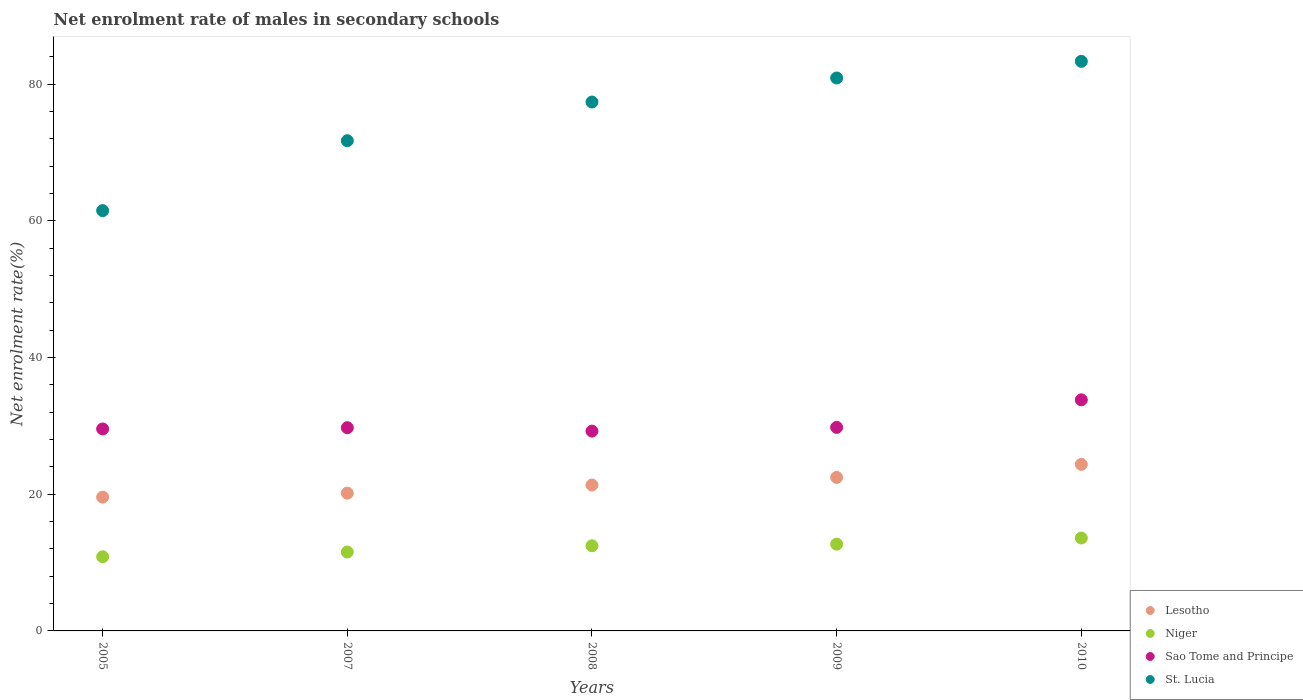Is the number of dotlines equal to the number of legend labels?
Your answer should be compact. Yes. What is the net enrolment rate of males in secondary schools in Niger in 2009?
Offer a terse response. 12.7. Across all years, what is the maximum net enrolment rate of males in secondary schools in Sao Tome and Principe?
Provide a short and direct response. 33.8. Across all years, what is the minimum net enrolment rate of males in secondary schools in Niger?
Your response must be concise. 10.85. In which year was the net enrolment rate of males in secondary schools in St. Lucia maximum?
Give a very brief answer. 2010. In which year was the net enrolment rate of males in secondary schools in Sao Tome and Principe minimum?
Offer a terse response. 2008. What is the total net enrolment rate of males in secondary schools in Sao Tome and Principe in the graph?
Offer a terse response. 152.09. What is the difference between the net enrolment rate of males in secondary schools in Sao Tome and Principe in 2005 and that in 2010?
Provide a short and direct response. -4.26. What is the difference between the net enrolment rate of males in secondary schools in Sao Tome and Principe in 2008 and the net enrolment rate of males in secondary schools in Niger in 2007?
Offer a very short reply. 17.69. What is the average net enrolment rate of males in secondary schools in Lesotho per year?
Provide a succinct answer. 21.58. In the year 2005, what is the difference between the net enrolment rate of males in secondary schools in Lesotho and net enrolment rate of males in secondary schools in Sao Tome and Principe?
Your response must be concise. -9.97. What is the ratio of the net enrolment rate of males in secondary schools in Lesotho in 2005 to that in 2007?
Your answer should be compact. 0.97. Is the difference between the net enrolment rate of males in secondary schools in Lesotho in 2008 and 2010 greater than the difference between the net enrolment rate of males in secondary schools in Sao Tome and Principe in 2008 and 2010?
Make the answer very short. Yes. What is the difference between the highest and the second highest net enrolment rate of males in secondary schools in St. Lucia?
Provide a succinct answer. 2.43. What is the difference between the highest and the lowest net enrolment rate of males in secondary schools in Lesotho?
Offer a terse response. 4.79. In how many years, is the net enrolment rate of males in secondary schools in Sao Tome and Principe greater than the average net enrolment rate of males in secondary schools in Sao Tome and Principe taken over all years?
Make the answer very short. 1. Is the sum of the net enrolment rate of males in secondary schools in Niger in 2007 and 2010 greater than the maximum net enrolment rate of males in secondary schools in Lesotho across all years?
Keep it short and to the point. Yes. Is the net enrolment rate of males in secondary schools in Sao Tome and Principe strictly less than the net enrolment rate of males in secondary schools in Lesotho over the years?
Offer a very short reply. No. How many dotlines are there?
Provide a succinct answer. 4. Where does the legend appear in the graph?
Your answer should be very brief. Bottom right. How many legend labels are there?
Give a very brief answer. 4. What is the title of the graph?
Your answer should be very brief. Net enrolment rate of males in secondary schools. Does "Uruguay" appear as one of the legend labels in the graph?
Make the answer very short. No. What is the label or title of the X-axis?
Offer a terse response. Years. What is the label or title of the Y-axis?
Ensure brevity in your answer.  Net enrolment rate(%). What is the Net enrolment rate(%) in Lesotho in 2005?
Provide a short and direct response. 19.57. What is the Net enrolment rate(%) of Niger in 2005?
Your answer should be very brief. 10.85. What is the Net enrolment rate(%) in Sao Tome and Principe in 2005?
Offer a terse response. 29.54. What is the Net enrolment rate(%) in St. Lucia in 2005?
Offer a very short reply. 61.48. What is the Net enrolment rate(%) of Lesotho in 2007?
Your answer should be compact. 20.15. What is the Net enrolment rate(%) in Niger in 2007?
Your answer should be compact. 11.54. What is the Net enrolment rate(%) of Sao Tome and Principe in 2007?
Offer a terse response. 29.73. What is the Net enrolment rate(%) in St. Lucia in 2007?
Your answer should be compact. 71.71. What is the Net enrolment rate(%) of Lesotho in 2008?
Provide a short and direct response. 21.34. What is the Net enrolment rate(%) in Niger in 2008?
Your answer should be compact. 12.46. What is the Net enrolment rate(%) in Sao Tome and Principe in 2008?
Offer a very short reply. 29.23. What is the Net enrolment rate(%) in St. Lucia in 2008?
Provide a succinct answer. 77.37. What is the Net enrolment rate(%) in Lesotho in 2009?
Your response must be concise. 22.46. What is the Net enrolment rate(%) of Niger in 2009?
Offer a terse response. 12.7. What is the Net enrolment rate(%) in Sao Tome and Principe in 2009?
Offer a terse response. 29.78. What is the Net enrolment rate(%) of St. Lucia in 2009?
Make the answer very short. 80.89. What is the Net enrolment rate(%) in Lesotho in 2010?
Ensure brevity in your answer.  24.36. What is the Net enrolment rate(%) in Niger in 2010?
Provide a succinct answer. 13.59. What is the Net enrolment rate(%) in Sao Tome and Principe in 2010?
Ensure brevity in your answer.  33.8. What is the Net enrolment rate(%) of St. Lucia in 2010?
Offer a very short reply. 83.32. Across all years, what is the maximum Net enrolment rate(%) in Lesotho?
Your answer should be very brief. 24.36. Across all years, what is the maximum Net enrolment rate(%) in Niger?
Provide a short and direct response. 13.59. Across all years, what is the maximum Net enrolment rate(%) of Sao Tome and Principe?
Give a very brief answer. 33.8. Across all years, what is the maximum Net enrolment rate(%) of St. Lucia?
Offer a terse response. 83.32. Across all years, what is the minimum Net enrolment rate(%) in Lesotho?
Make the answer very short. 19.57. Across all years, what is the minimum Net enrolment rate(%) of Niger?
Give a very brief answer. 10.85. Across all years, what is the minimum Net enrolment rate(%) in Sao Tome and Principe?
Offer a very short reply. 29.23. Across all years, what is the minimum Net enrolment rate(%) in St. Lucia?
Offer a terse response. 61.48. What is the total Net enrolment rate(%) in Lesotho in the graph?
Your answer should be compact. 107.89. What is the total Net enrolment rate(%) of Niger in the graph?
Ensure brevity in your answer.  61.13. What is the total Net enrolment rate(%) in Sao Tome and Principe in the graph?
Provide a short and direct response. 152.09. What is the total Net enrolment rate(%) of St. Lucia in the graph?
Your response must be concise. 374.76. What is the difference between the Net enrolment rate(%) in Lesotho in 2005 and that in 2007?
Provide a short and direct response. -0.58. What is the difference between the Net enrolment rate(%) in Niger in 2005 and that in 2007?
Provide a succinct answer. -0.69. What is the difference between the Net enrolment rate(%) of Sao Tome and Principe in 2005 and that in 2007?
Provide a succinct answer. -0.18. What is the difference between the Net enrolment rate(%) in St. Lucia in 2005 and that in 2007?
Offer a very short reply. -10.23. What is the difference between the Net enrolment rate(%) of Lesotho in 2005 and that in 2008?
Provide a succinct answer. -1.77. What is the difference between the Net enrolment rate(%) in Niger in 2005 and that in 2008?
Keep it short and to the point. -1.61. What is the difference between the Net enrolment rate(%) in Sao Tome and Principe in 2005 and that in 2008?
Your answer should be very brief. 0.31. What is the difference between the Net enrolment rate(%) of St. Lucia in 2005 and that in 2008?
Make the answer very short. -15.89. What is the difference between the Net enrolment rate(%) in Lesotho in 2005 and that in 2009?
Your response must be concise. -2.88. What is the difference between the Net enrolment rate(%) in Niger in 2005 and that in 2009?
Provide a short and direct response. -1.85. What is the difference between the Net enrolment rate(%) of Sao Tome and Principe in 2005 and that in 2009?
Offer a terse response. -0.23. What is the difference between the Net enrolment rate(%) in St. Lucia in 2005 and that in 2009?
Make the answer very short. -19.41. What is the difference between the Net enrolment rate(%) in Lesotho in 2005 and that in 2010?
Your answer should be very brief. -4.79. What is the difference between the Net enrolment rate(%) of Niger in 2005 and that in 2010?
Your response must be concise. -2.74. What is the difference between the Net enrolment rate(%) in Sao Tome and Principe in 2005 and that in 2010?
Your response must be concise. -4.26. What is the difference between the Net enrolment rate(%) of St. Lucia in 2005 and that in 2010?
Provide a short and direct response. -21.84. What is the difference between the Net enrolment rate(%) of Lesotho in 2007 and that in 2008?
Provide a succinct answer. -1.19. What is the difference between the Net enrolment rate(%) of Niger in 2007 and that in 2008?
Your response must be concise. -0.92. What is the difference between the Net enrolment rate(%) of Sao Tome and Principe in 2007 and that in 2008?
Your answer should be compact. 0.5. What is the difference between the Net enrolment rate(%) of St. Lucia in 2007 and that in 2008?
Your response must be concise. -5.66. What is the difference between the Net enrolment rate(%) in Lesotho in 2007 and that in 2009?
Your response must be concise. -2.3. What is the difference between the Net enrolment rate(%) of Niger in 2007 and that in 2009?
Your answer should be compact. -1.15. What is the difference between the Net enrolment rate(%) in Sao Tome and Principe in 2007 and that in 2009?
Give a very brief answer. -0.05. What is the difference between the Net enrolment rate(%) in St. Lucia in 2007 and that in 2009?
Offer a terse response. -9.18. What is the difference between the Net enrolment rate(%) of Lesotho in 2007 and that in 2010?
Provide a short and direct response. -4.21. What is the difference between the Net enrolment rate(%) in Niger in 2007 and that in 2010?
Offer a terse response. -2.05. What is the difference between the Net enrolment rate(%) in Sao Tome and Principe in 2007 and that in 2010?
Your response must be concise. -4.08. What is the difference between the Net enrolment rate(%) in St. Lucia in 2007 and that in 2010?
Your answer should be very brief. -11.61. What is the difference between the Net enrolment rate(%) in Lesotho in 2008 and that in 2009?
Your answer should be very brief. -1.12. What is the difference between the Net enrolment rate(%) of Niger in 2008 and that in 2009?
Your answer should be compact. -0.24. What is the difference between the Net enrolment rate(%) of Sao Tome and Principe in 2008 and that in 2009?
Your answer should be very brief. -0.55. What is the difference between the Net enrolment rate(%) in St. Lucia in 2008 and that in 2009?
Your response must be concise. -3.52. What is the difference between the Net enrolment rate(%) in Lesotho in 2008 and that in 2010?
Provide a short and direct response. -3.02. What is the difference between the Net enrolment rate(%) of Niger in 2008 and that in 2010?
Offer a terse response. -1.13. What is the difference between the Net enrolment rate(%) in Sao Tome and Principe in 2008 and that in 2010?
Give a very brief answer. -4.58. What is the difference between the Net enrolment rate(%) of St. Lucia in 2008 and that in 2010?
Offer a very short reply. -5.95. What is the difference between the Net enrolment rate(%) in Lesotho in 2009 and that in 2010?
Provide a short and direct response. -1.91. What is the difference between the Net enrolment rate(%) of Niger in 2009 and that in 2010?
Your answer should be very brief. -0.89. What is the difference between the Net enrolment rate(%) in Sao Tome and Principe in 2009 and that in 2010?
Provide a short and direct response. -4.03. What is the difference between the Net enrolment rate(%) in St. Lucia in 2009 and that in 2010?
Make the answer very short. -2.43. What is the difference between the Net enrolment rate(%) in Lesotho in 2005 and the Net enrolment rate(%) in Niger in 2007?
Ensure brevity in your answer.  8.03. What is the difference between the Net enrolment rate(%) in Lesotho in 2005 and the Net enrolment rate(%) in Sao Tome and Principe in 2007?
Your response must be concise. -10.16. What is the difference between the Net enrolment rate(%) of Lesotho in 2005 and the Net enrolment rate(%) of St. Lucia in 2007?
Your response must be concise. -52.14. What is the difference between the Net enrolment rate(%) of Niger in 2005 and the Net enrolment rate(%) of Sao Tome and Principe in 2007?
Your answer should be very brief. -18.88. What is the difference between the Net enrolment rate(%) in Niger in 2005 and the Net enrolment rate(%) in St. Lucia in 2007?
Provide a short and direct response. -60.86. What is the difference between the Net enrolment rate(%) in Sao Tome and Principe in 2005 and the Net enrolment rate(%) in St. Lucia in 2007?
Provide a short and direct response. -42.17. What is the difference between the Net enrolment rate(%) in Lesotho in 2005 and the Net enrolment rate(%) in Niger in 2008?
Your answer should be very brief. 7.11. What is the difference between the Net enrolment rate(%) of Lesotho in 2005 and the Net enrolment rate(%) of Sao Tome and Principe in 2008?
Make the answer very short. -9.66. What is the difference between the Net enrolment rate(%) in Lesotho in 2005 and the Net enrolment rate(%) in St. Lucia in 2008?
Your answer should be very brief. -57.8. What is the difference between the Net enrolment rate(%) in Niger in 2005 and the Net enrolment rate(%) in Sao Tome and Principe in 2008?
Your answer should be compact. -18.38. What is the difference between the Net enrolment rate(%) of Niger in 2005 and the Net enrolment rate(%) of St. Lucia in 2008?
Offer a terse response. -66.52. What is the difference between the Net enrolment rate(%) in Sao Tome and Principe in 2005 and the Net enrolment rate(%) in St. Lucia in 2008?
Provide a short and direct response. -47.82. What is the difference between the Net enrolment rate(%) of Lesotho in 2005 and the Net enrolment rate(%) of Niger in 2009?
Ensure brevity in your answer.  6.88. What is the difference between the Net enrolment rate(%) of Lesotho in 2005 and the Net enrolment rate(%) of Sao Tome and Principe in 2009?
Your answer should be compact. -10.2. What is the difference between the Net enrolment rate(%) of Lesotho in 2005 and the Net enrolment rate(%) of St. Lucia in 2009?
Provide a short and direct response. -61.32. What is the difference between the Net enrolment rate(%) of Niger in 2005 and the Net enrolment rate(%) of Sao Tome and Principe in 2009?
Make the answer very short. -18.93. What is the difference between the Net enrolment rate(%) of Niger in 2005 and the Net enrolment rate(%) of St. Lucia in 2009?
Offer a terse response. -70.04. What is the difference between the Net enrolment rate(%) of Sao Tome and Principe in 2005 and the Net enrolment rate(%) of St. Lucia in 2009?
Your answer should be very brief. -51.34. What is the difference between the Net enrolment rate(%) in Lesotho in 2005 and the Net enrolment rate(%) in Niger in 2010?
Your answer should be compact. 5.98. What is the difference between the Net enrolment rate(%) in Lesotho in 2005 and the Net enrolment rate(%) in Sao Tome and Principe in 2010?
Make the answer very short. -14.23. What is the difference between the Net enrolment rate(%) of Lesotho in 2005 and the Net enrolment rate(%) of St. Lucia in 2010?
Ensure brevity in your answer.  -63.75. What is the difference between the Net enrolment rate(%) of Niger in 2005 and the Net enrolment rate(%) of Sao Tome and Principe in 2010?
Ensure brevity in your answer.  -22.96. What is the difference between the Net enrolment rate(%) of Niger in 2005 and the Net enrolment rate(%) of St. Lucia in 2010?
Your answer should be compact. -72.47. What is the difference between the Net enrolment rate(%) in Sao Tome and Principe in 2005 and the Net enrolment rate(%) in St. Lucia in 2010?
Your answer should be very brief. -53.77. What is the difference between the Net enrolment rate(%) of Lesotho in 2007 and the Net enrolment rate(%) of Niger in 2008?
Provide a succinct answer. 7.7. What is the difference between the Net enrolment rate(%) of Lesotho in 2007 and the Net enrolment rate(%) of Sao Tome and Principe in 2008?
Give a very brief answer. -9.08. What is the difference between the Net enrolment rate(%) in Lesotho in 2007 and the Net enrolment rate(%) in St. Lucia in 2008?
Make the answer very short. -57.21. What is the difference between the Net enrolment rate(%) of Niger in 2007 and the Net enrolment rate(%) of Sao Tome and Principe in 2008?
Your answer should be compact. -17.69. What is the difference between the Net enrolment rate(%) of Niger in 2007 and the Net enrolment rate(%) of St. Lucia in 2008?
Ensure brevity in your answer.  -65.83. What is the difference between the Net enrolment rate(%) of Sao Tome and Principe in 2007 and the Net enrolment rate(%) of St. Lucia in 2008?
Your answer should be compact. -47.64. What is the difference between the Net enrolment rate(%) in Lesotho in 2007 and the Net enrolment rate(%) in Niger in 2009?
Your answer should be very brief. 7.46. What is the difference between the Net enrolment rate(%) of Lesotho in 2007 and the Net enrolment rate(%) of Sao Tome and Principe in 2009?
Ensure brevity in your answer.  -9.62. What is the difference between the Net enrolment rate(%) of Lesotho in 2007 and the Net enrolment rate(%) of St. Lucia in 2009?
Your response must be concise. -60.73. What is the difference between the Net enrolment rate(%) in Niger in 2007 and the Net enrolment rate(%) in Sao Tome and Principe in 2009?
Make the answer very short. -18.24. What is the difference between the Net enrolment rate(%) of Niger in 2007 and the Net enrolment rate(%) of St. Lucia in 2009?
Your answer should be very brief. -69.35. What is the difference between the Net enrolment rate(%) of Sao Tome and Principe in 2007 and the Net enrolment rate(%) of St. Lucia in 2009?
Make the answer very short. -51.16. What is the difference between the Net enrolment rate(%) in Lesotho in 2007 and the Net enrolment rate(%) in Niger in 2010?
Provide a succinct answer. 6.57. What is the difference between the Net enrolment rate(%) in Lesotho in 2007 and the Net enrolment rate(%) in Sao Tome and Principe in 2010?
Ensure brevity in your answer.  -13.65. What is the difference between the Net enrolment rate(%) in Lesotho in 2007 and the Net enrolment rate(%) in St. Lucia in 2010?
Your answer should be very brief. -63.17. What is the difference between the Net enrolment rate(%) of Niger in 2007 and the Net enrolment rate(%) of Sao Tome and Principe in 2010?
Provide a short and direct response. -22.26. What is the difference between the Net enrolment rate(%) in Niger in 2007 and the Net enrolment rate(%) in St. Lucia in 2010?
Provide a short and direct response. -71.78. What is the difference between the Net enrolment rate(%) in Sao Tome and Principe in 2007 and the Net enrolment rate(%) in St. Lucia in 2010?
Provide a short and direct response. -53.59. What is the difference between the Net enrolment rate(%) in Lesotho in 2008 and the Net enrolment rate(%) in Niger in 2009?
Offer a very short reply. 8.65. What is the difference between the Net enrolment rate(%) in Lesotho in 2008 and the Net enrolment rate(%) in Sao Tome and Principe in 2009?
Make the answer very short. -8.44. What is the difference between the Net enrolment rate(%) in Lesotho in 2008 and the Net enrolment rate(%) in St. Lucia in 2009?
Ensure brevity in your answer.  -59.55. What is the difference between the Net enrolment rate(%) in Niger in 2008 and the Net enrolment rate(%) in Sao Tome and Principe in 2009?
Your answer should be very brief. -17.32. What is the difference between the Net enrolment rate(%) in Niger in 2008 and the Net enrolment rate(%) in St. Lucia in 2009?
Keep it short and to the point. -68.43. What is the difference between the Net enrolment rate(%) in Sao Tome and Principe in 2008 and the Net enrolment rate(%) in St. Lucia in 2009?
Keep it short and to the point. -51.66. What is the difference between the Net enrolment rate(%) of Lesotho in 2008 and the Net enrolment rate(%) of Niger in 2010?
Keep it short and to the point. 7.75. What is the difference between the Net enrolment rate(%) of Lesotho in 2008 and the Net enrolment rate(%) of Sao Tome and Principe in 2010?
Offer a terse response. -12.46. What is the difference between the Net enrolment rate(%) in Lesotho in 2008 and the Net enrolment rate(%) in St. Lucia in 2010?
Provide a succinct answer. -61.98. What is the difference between the Net enrolment rate(%) of Niger in 2008 and the Net enrolment rate(%) of Sao Tome and Principe in 2010?
Keep it short and to the point. -21.35. What is the difference between the Net enrolment rate(%) of Niger in 2008 and the Net enrolment rate(%) of St. Lucia in 2010?
Offer a very short reply. -70.86. What is the difference between the Net enrolment rate(%) in Sao Tome and Principe in 2008 and the Net enrolment rate(%) in St. Lucia in 2010?
Your answer should be very brief. -54.09. What is the difference between the Net enrolment rate(%) in Lesotho in 2009 and the Net enrolment rate(%) in Niger in 2010?
Offer a terse response. 8.87. What is the difference between the Net enrolment rate(%) in Lesotho in 2009 and the Net enrolment rate(%) in Sao Tome and Principe in 2010?
Your answer should be compact. -11.35. What is the difference between the Net enrolment rate(%) in Lesotho in 2009 and the Net enrolment rate(%) in St. Lucia in 2010?
Keep it short and to the point. -60.86. What is the difference between the Net enrolment rate(%) in Niger in 2009 and the Net enrolment rate(%) in Sao Tome and Principe in 2010?
Make the answer very short. -21.11. What is the difference between the Net enrolment rate(%) of Niger in 2009 and the Net enrolment rate(%) of St. Lucia in 2010?
Give a very brief answer. -70.62. What is the difference between the Net enrolment rate(%) in Sao Tome and Principe in 2009 and the Net enrolment rate(%) in St. Lucia in 2010?
Provide a short and direct response. -53.54. What is the average Net enrolment rate(%) in Lesotho per year?
Make the answer very short. 21.58. What is the average Net enrolment rate(%) of Niger per year?
Your answer should be compact. 12.23. What is the average Net enrolment rate(%) of Sao Tome and Principe per year?
Give a very brief answer. 30.42. What is the average Net enrolment rate(%) in St. Lucia per year?
Your answer should be compact. 74.95. In the year 2005, what is the difference between the Net enrolment rate(%) of Lesotho and Net enrolment rate(%) of Niger?
Ensure brevity in your answer.  8.72. In the year 2005, what is the difference between the Net enrolment rate(%) in Lesotho and Net enrolment rate(%) in Sao Tome and Principe?
Offer a very short reply. -9.97. In the year 2005, what is the difference between the Net enrolment rate(%) of Lesotho and Net enrolment rate(%) of St. Lucia?
Offer a terse response. -41.91. In the year 2005, what is the difference between the Net enrolment rate(%) in Niger and Net enrolment rate(%) in Sao Tome and Principe?
Keep it short and to the point. -18.7. In the year 2005, what is the difference between the Net enrolment rate(%) in Niger and Net enrolment rate(%) in St. Lucia?
Offer a terse response. -50.63. In the year 2005, what is the difference between the Net enrolment rate(%) of Sao Tome and Principe and Net enrolment rate(%) of St. Lucia?
Provide a short and direct response. -31.93. In the year 2007, what is the difference between the Net enrolment rate(%) in Lesotho and Net enrolment rate(%) in Niger?
Keep it short and to the point. 8.61. In the year 2007, what is the difference between the Net enrolment rate(%) of Lesotho and Net enrolment rate(%) of Sao Tome and Principe?
Your response must be concise. -9.57. In the year 2007, what is the difference between the Net enrolment rate(%) of Lesotho and Net enrolment rate(%) of St. Lucia?
Make the answer very short. -51.56. In the year 2007, what is the difference between the Net enrolment rate(%) of Niger and Net enrolment rate(%) of Sao Tome and Principe?
Your response must be concise. -18.19. In the year 2007, what is the difference between the Net enrolment rate(%) in Niger and Net enrolment rate(%) in St. Lucia?
Ensure brevity in your answer.  -60.17. In the year 2007, what is the difference between the Net enrolment rate(%) of Sao Tome and Principe and Net enrolment rate(%) of St. Lucia?
Provide a succinct answer. -41.98. In the year 2008, what is the difference between the Net enrolment rate(%) in Lesotho and Net enrolment rate(%) in Niger?
Your response must be concise. 8.88. In the year 2008, what is the difference between the Net enrolment rate(%) of Lesotho and Net enrolment rate(%) of Sao Tome and Principe?
Your response must be concise. -7.89. In the year 2008, what is the difference between the Net enrolment rate(%) in Lesotho and Net enrolment rate(%) in St. Lucia?
Your answer should be very brief. -56.03. In the year 2008, what is the difference between the Net enrolment rate(%) of Niger and Net enrolment rate(%) of Sao Tome and Principe?
Provide a succinct answer. -16.77. In the year 2008, what is the difference between the Net enrolment rate(%) in Niger and Net enrolment rate(%) in St. Lucia?
Make the answer very short. -64.91. In the year 2008, what is the difference between the Net enrolment rate(%) of Sao Tome and Principe and Net enrolment rate(%) of St. Lucia?
Offer a very short reply. -48.14. In the year 2009, what is the difference between the Net enrolment rate(%) of Lesotho and Net enrolment rate(%) of Niger?
Ensure brevity in your answer.  9.76. In the year 2009, what is the difference between the Net enrolment rate(%) in Lesotho and Net enrolment rate(%) in Sao Tome and Principe?
Offer a terse response. -7.32. In the year 2009, what is the difference between the Net enrolment rate(%) of Lesotho and Net enrolment rate(%) of St. Lucia?
Provide a short and direct response. -58.43. In the year 2009, what is the difference between the Net enrolment rate(%) in Niger and Net enrolment rate(%) in Sao Tome and Principe?
Make the answer very short. -17.08. In the year 2009, what is the difference between the Net enrolment rate(%) of Niger and Net enrolment rate(%) of St. Lucia?
Offer a very short reply. -68.19. In the year 2009, what is the difference between the Net enrolment rate(%) in Sao Tome and Principe and Net enrolment rate(%) in St. Lucia?
Provide a succinct answer. -51.11. In the year 2010, what is the difference between the Net enrolment rate(%) of Lesotho and Net enrolment rate(%) of Niger?
Offer a very short reply. 10.78. In the year 2010, what is the difference between the Net enrolment rate(%) in Lesotho and Net enrolment rate(%) in Sao Tome and Principe?
Keep it short and to the point. -9.44. In the year 2010, what is the difference between the Net enrolment rate(%) of Lesotho and Net enrolment rate(%) of St. Lucia?
Ensure brevity in your answer.  -58.95. In the year 2010, what is the difference between the Net enrolment rate(%) of Niger and Net enrolment rate(%) of Sao Tome and Principe?
Provide a short and direct response. -20.22. In the year 2010, what is the difference between the Net enrolment rate(%) in Niger and Net enrolment rate(%) in St. Lucia?
Keep it short and to the point. -69.73. In the year 2010, what is the difference between the Net enrolment rate(%) in Sao Tome and Principe and Net enrolment rate(%) in St. Lucia?
Keep it short and to the point. -49.51. What is the ratio of the Net enrolment rate(%) in Lesotho in 2005 to that in 2007?
Keep it short and to the point. 0.97. What is the ratio of the Net enrolment rate(%) of Niger in 2005 to that in 2007?
Your answer should be very brief. 0.94. What is the ratio of the Net enrolment rate(%) of St. Lucia in 2005 to that in 2007?
Give a very brief answer. 0.86. What is the ratio of the Net enrolment rate(%) of Lesotho in 2005 to that in 2008?
Ensure brevity in your answer.  0.92. What is the ratio of the Net enrolment rate(%) in Niger in 2005 to that in 2008?
Your response must be concise. 0.87. What is the ratio of the Net enrolment rate(%) of Sao Tome and Principe in 2005 to that in 2008?
Give a very brief answer. 1.01. What is the ratio of the Net enrolment rate(%) of St. Lucia in 2005 to that in 2008?
Provide a short and direct response. 0.79. What is the ratio of the Net enrolment rate(%) in Lesotho in 2005 to that in 2009?
Provide a succinct answer. 0.87. What is the ratio of the Net enrolment rate(%) of Niger in 2005 to that in 2009?
Ensure brevity in your answer.  0.85. What is the ratio of the Net enrolment rate(%) in Sao Tome and Principe in 2005 to that in 2009?
Ensure brevity in your answer.  0.99. What is the ratio of the Net enrolment rate(%) of St. Lucia in 2005 to that in 2009?
Provide a short and direct response. 0.76. What is the ratio of the Net enrolment rate(%) of Lesotho in 2005 to that in 2010?
Your answer should be compact. 0.8. What is the ratio of the Net enrolment rate(%) of Niger in 2005 to that in 2010?
Offer a very short reply. 0.8. What is the ratio of the Net enrolment rate(%) in Sao Tome and Principe in 2005 to that in 2010?
Keep it short and to the point. 0.87. What is the ratio of the Net enrolment rate(%) in St. Lucia in 2005 to that in 2010?
Ensure brevity in your answer.  0.74. What is the ratio of the Net enrolment rate(%) of Lesotho in 2007 to that in 2008?
Offer a terse response. 0.94. What is the ratio of the Net enrolment rate(%) in Niger in 2007 to that in 2008?
Ensure brevity in your answer.  0.93. What is the ratio of the Net enrolment rate(%) of Sao Tome and Principe in 2007 to that in 2008?
Offer a terse response. 1.02. What is the ratio of the Net enrolment rate(%) of St. Lucia in 2007 to that in 2008?
Give a very brief answer. 0.93. What is the ratio of the Net enrolment rate(%) in Lesotho in 2007 to that in 2009?
Give a very brief answer. 0.9. What is the ratio of the Net enrolment rate(%) of Niger in 2007 to that in 2009?
Your answer should be compact. 0.91. What is the ratio of the Net enrolment rate(%) of Sao Tome and Principe in 2007 to that in 2009?
Provide a short and direct response. 1. What is the ratio of the Net enrolment rate(%) in St. Lucia in 2007 to that in 2009?
Give a very brief answer. 0.89. What is the ratio of the Net enrolment rate(%) of Lesotho in 2007 to that in 2010?
Offer a terse response. 0.83. What is the ratio of the Net enrolment rate(%) of Niger in 2007 to that in 2010?
Offer a terse response. 0.85. What is the ratio of the Net enrolment rate(%) of Sao Tome and Principe in 2007 to that in 2010?
Provide a short and direct response. 0.88. What is the ratio of the Net enrolment rate(%) of St. Lucia in 2007 to that in 2010?
Ensure brevity in your answer.  0.86. What is the ratio of the Net enrolment rate(%) of Lesotho in 2008 to that in 2009?
Make the answer very short. 0.95. What is the ratio of the Net enrolment rate(%) of Niger in 2008 to that in 2009?
Provide a short and direct response. 0.98. What is the ratio of the Net enrolment rate(%) in Sao Tome and Principe in 2008 to that in 2009?
Provide a short and direct response. 0.98. What is the ratio of the Net enrolment rate(%) in St. Lucia in 2008 to that in 2009?
Provide a succinct answer. 0.96. What is the ratio of the Net enrolment rate(%) of Lesotho in 2008 to that in 2010?
Your response must be concise. 0.88. What is the ratio of the Net enrolment rate(%) of Niger in 2008 to that in 2010?
Provide a succinct answer. 0.92. What is the ratio of the Net enrolment rate(%) in Sao Tome and Principe in 2008 to that in 2010?
Your answer should be compact. 0.86. What is the ratio of the Net enrolment rate(%) of St. Lucia in 2008 to that in 2010?
Offer a very short reply. 0.93. What is the ratio of the Net enrolment rate(%) in Lesotho in 2009 to that in 2010?
Your answer should be very brief. 0.92. What is the ratio of the Net enrolment rate(%) in Niger in 2009 to that in 2010?
Your response must be concise. 0.93. What is the ratio of the Net enrolment rate(%) in Sao Tome and Principe in 2009 to that in 2010?
Give a very brief answer. 0.88. What is the ratio of the Net enrolment rate(%) of St. Lucia in 2009 to that in 2010?
Your response must be concise. 0.97. What is the difference between the highest and the second highest Net enrolment rate(%) in Lesotho?
Offer a very short reply. 1.91. What is the difference between the highest and the second highest Net enrolment rate(%) of Niger?
Provide a short and direct response. 0.89. What is the difference between the highest and the second highest Net enrolment rate(%) of Sao Tome and Principe?
Your answer should be compact. 4.03. What is the difference between the highest and the second highest Net enrolment rate(%) in St. Lucia?
Give a very brief answer. 2.43. What is the difference between the highest and the lowest Net enrolment rate(%) of Lesotho?
Your answer should be very brief. 4.79. What is the difference between the highest and the lowest Net enrolment rate(%) in Niger?
Offer a very short reply. 2.74. What is the difference between the highest and the lowest Net enrolment rate(%) in Sao Tome and Principe?
Provide a short and direct response. 4.58. What is the difference between the highest and the lowest Net enrolment rate(%) of St. Lucia?
Your answer should be compact. 21.84. 